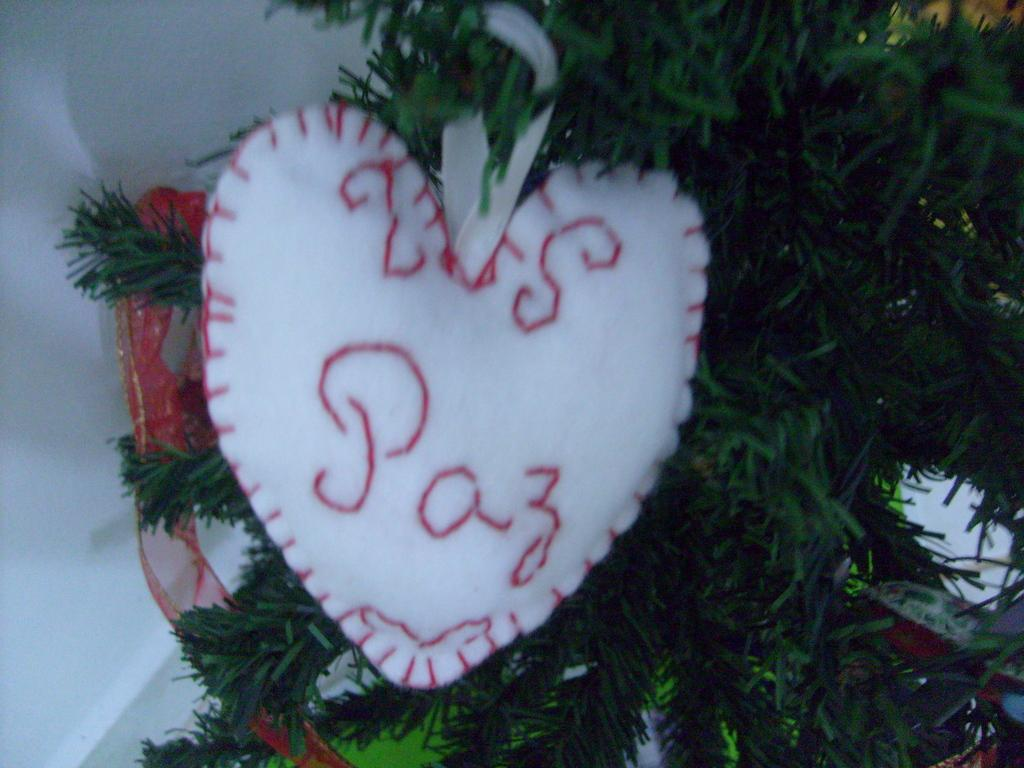What type of structure can be seen in the image? There is a wall in the image. What natural element is present in the image? There is a tree in the image. What type of object can be seen in the image? There is a heart-shaped pillow in the image. What type of linen is draped over the tree in the image? There is no linen draped over the tree in the image; it only features a tree and a wall. How does the heart-shaped pillow express regret in the image? The heart-shaped pillow does not express regret in the image, as it is an inanimate object and cannot have emotions or express feelings. 